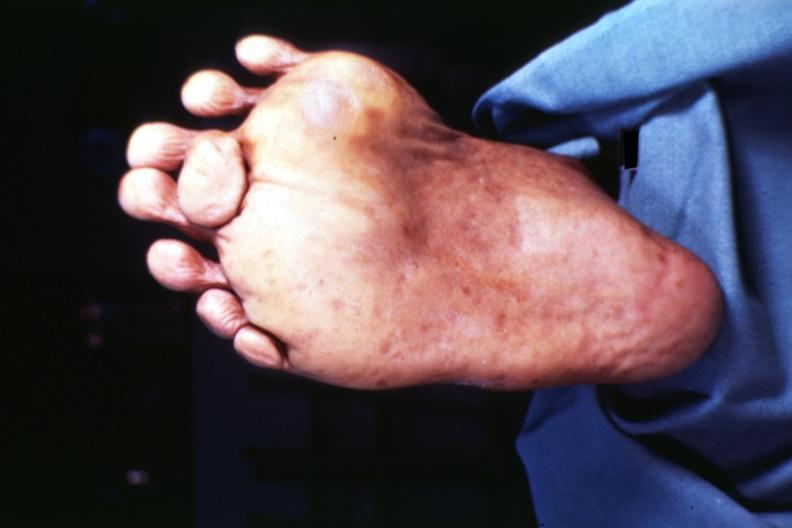what does this image show?
Answer the question using a single word or phrase. View of foot from plantar surface 7 toes at least 